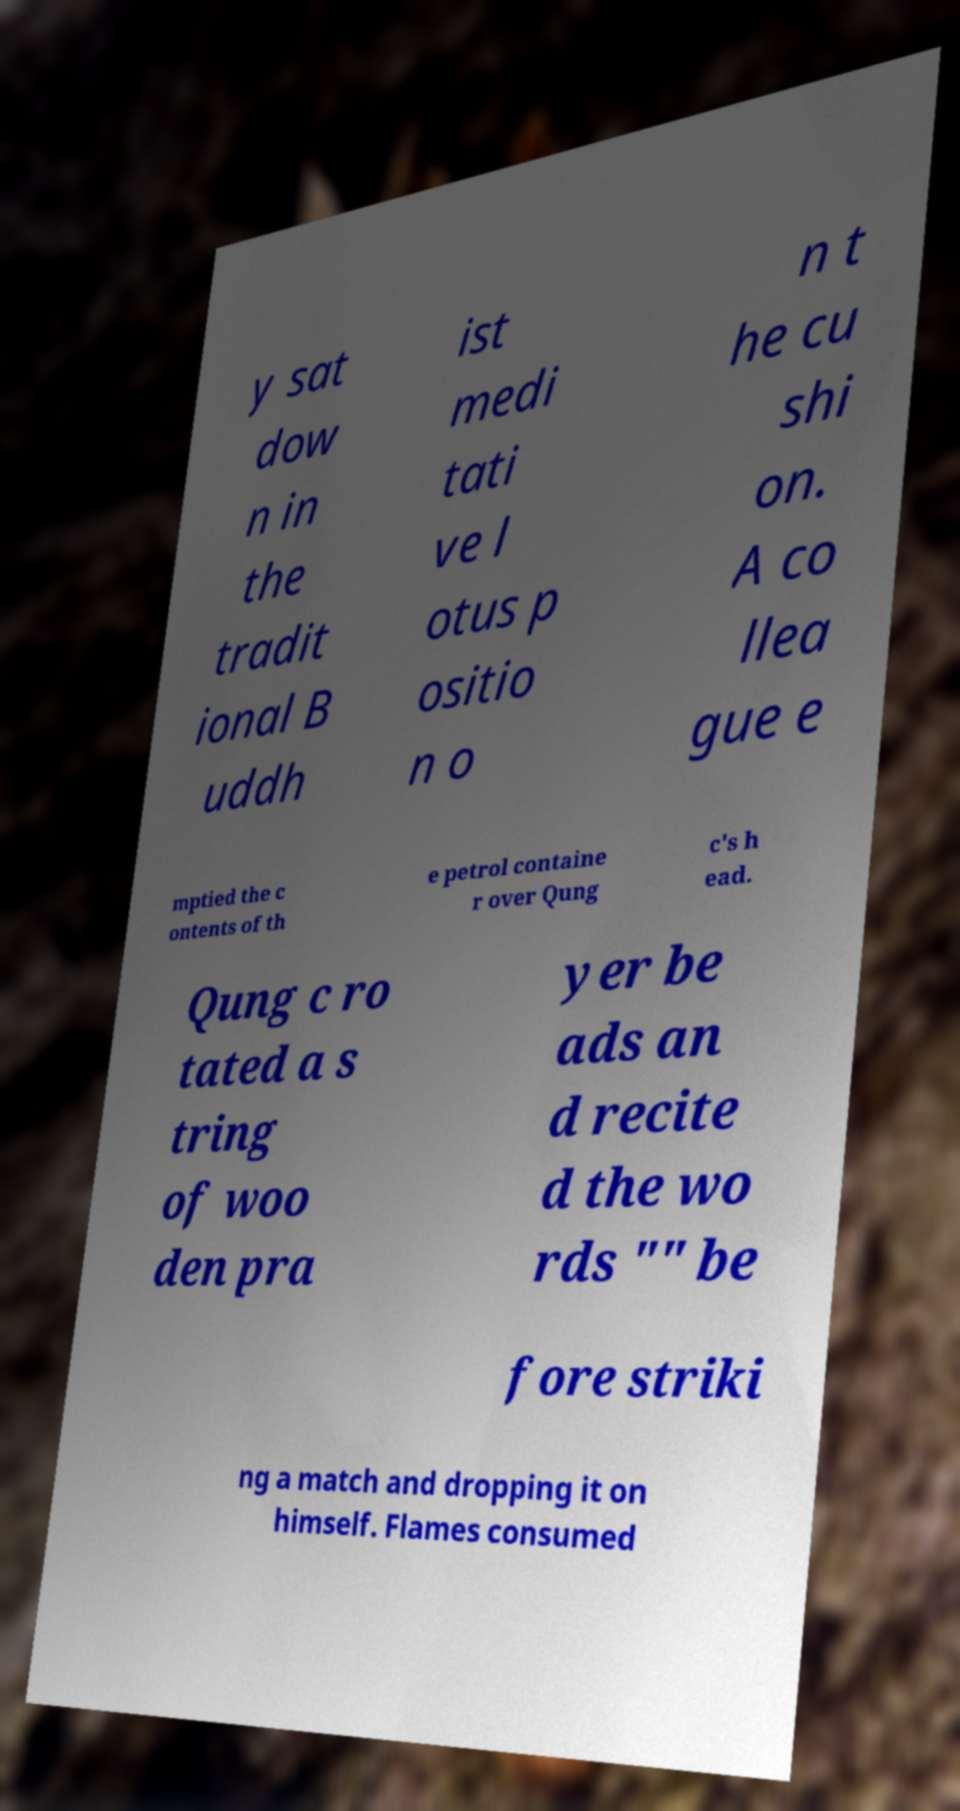For documentation purposes, I need the text within this image transcribed. Could you provide that? y sat dow n in the tradit ional B uddh ist medi tati ve l otus p ositio n o n t he cu shi on. A co llea gue e mptied the c ontents of th e petrol containe r over Qung c's h ead. Qung c ro tated a s tring of woo den pra yer be ads an d recite d the wo rds "" be fore striki ng a match and dropping it on himself. Flames consumed 